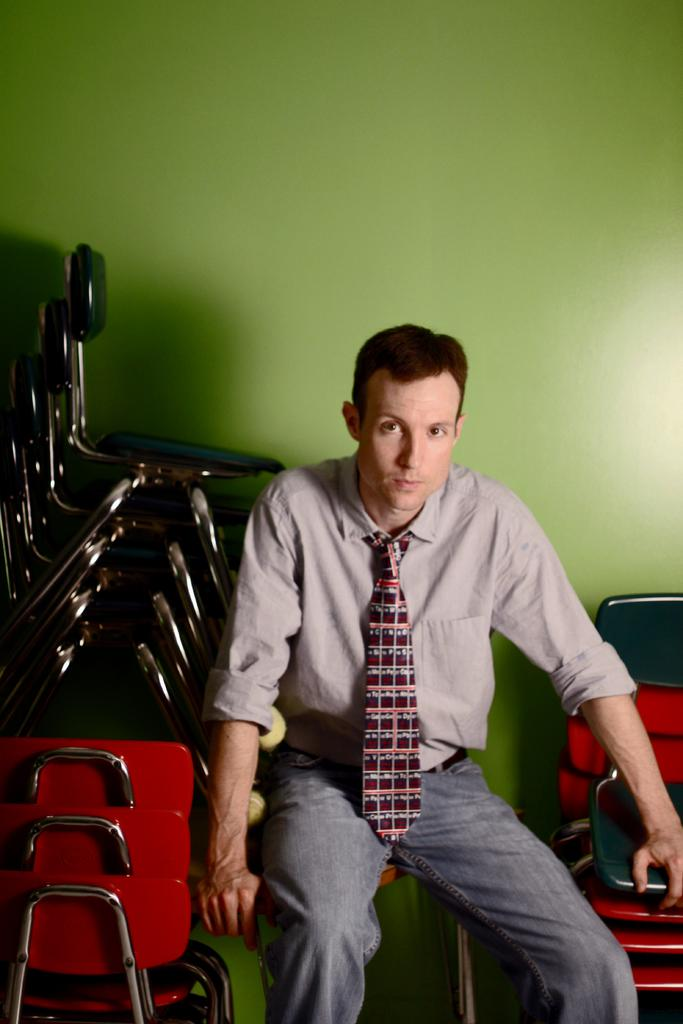Who is present in the image? There is a man in the image. What is the man wearing around his neck? The man is wearing a tie. What is the man's posture in the image? The man is sitting on a chair. How many chairs are visible in the image? There are chairs on both sides of the man, making a total of three chairs. What color is the wall in the background of the image? The wall in the background of the image is green-colored. What type of list is the man holding in the image? There is no list present in the image; the man is not holding anything. 